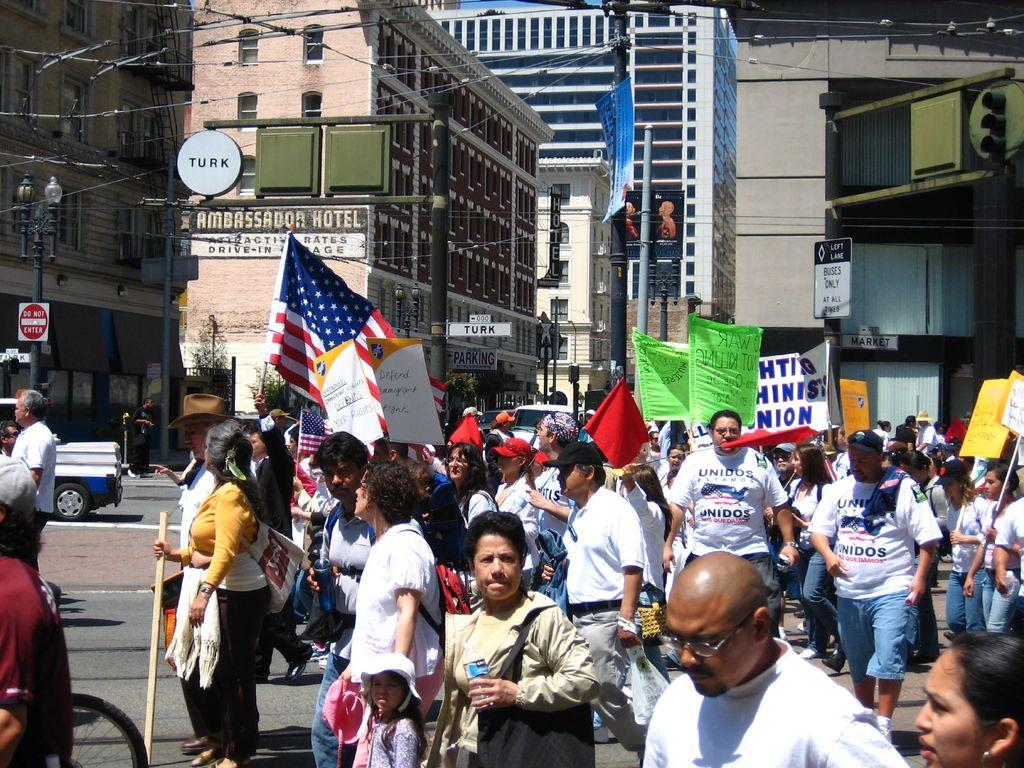What is happening on the road in the image? There is a group of people on the road in the image. What can be seen in addition to the people on the road? There are flags, posters, name boards, poles, vehicles, trees, and some objects in the image. What is visible in the background of the image? Buildings with windows are visible in the background. Is there any snow visible in the image? No, there is no snow present in the image. Can you tell me how the people in the image are enjoying their flight? There is no flight depicted in the image; it shows a group of people on the road. 